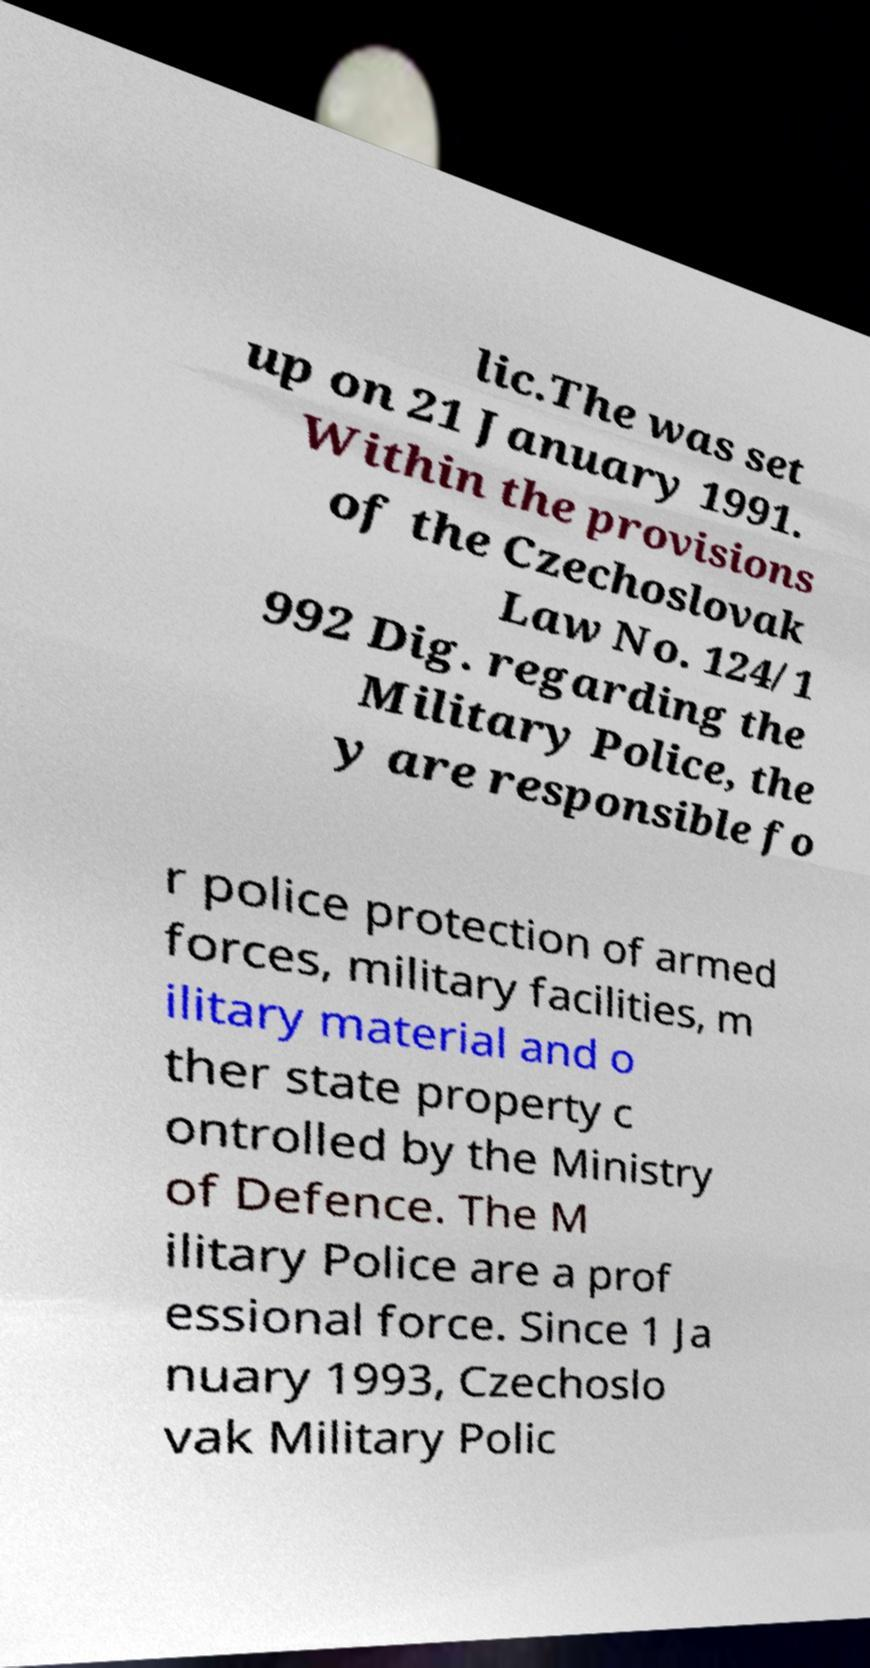Could you assist in decoding the text presented in this image and type it out clearly? lic.The was set up on 21 January 1991. Within the provisions of the Czechoslovak Law No. 124/1 992 Dig. regarding the Military Police, the y are responsible fo r police protection of armed forces, military facilities, m ilitary material and o ther state property c ontrolled by the Ministry of Defence. The M ilitary Police are a prof essional force. Since 1 Ja nuary 1993, Czechoslo vak Military Polic 